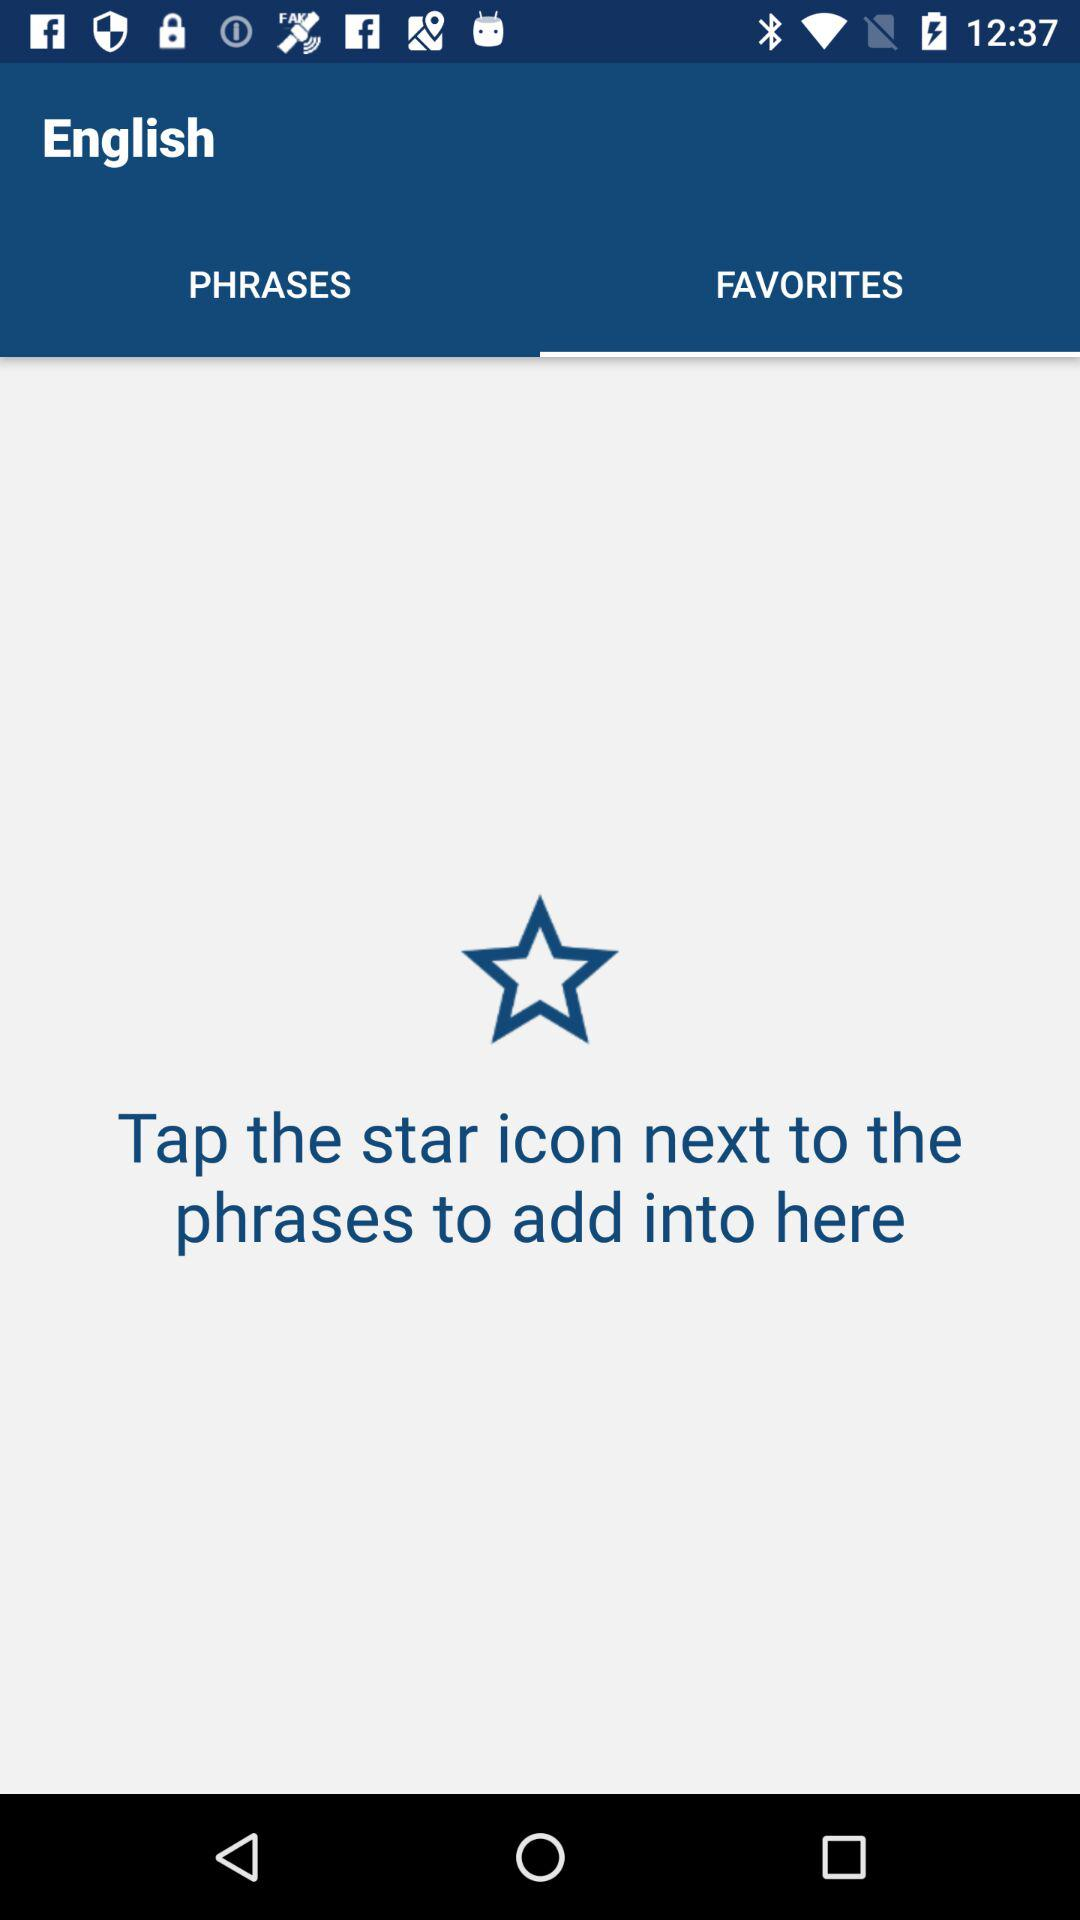What is the selected tab? The selected tab is Favorites. 